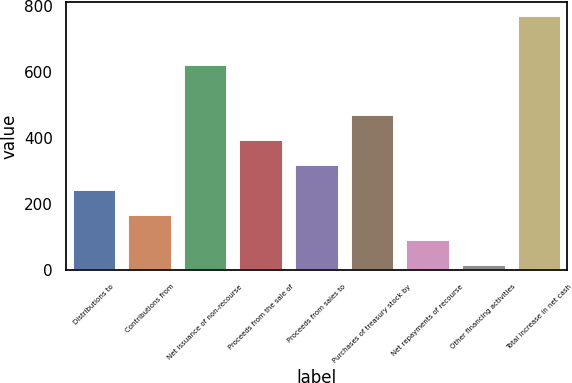Convert chart. <chart><loc_0><loc_0><loc_500><loc_500><bar_chart><fcel>Distributions to<fcel>Contributions from<fcel>Net issuance of non-recourse<fcel>Proceeds from the sale of<fcel>Proceeds from sales to<fcel>Purchases of treasury stock by<fcel>Net repayments of recourse<fcel>Other financing activities<fcel>Total increase in net cash<nl><fcel>245.8<fcel>170.2<fcel>624<fcel>397<fcel>321.4<fcel>472.6<fcel>94.6<fcel>19<fcel>775<nl></chart> 